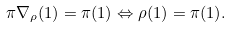<formula> <loc_0><loc_0><loc_500><loc_500>\pi \nabla _ { \rho } ( 1 ) = \pi ( 1 ) \Leftrightarrow \rho ( 1 ) = \pi ( 1 ) .</formula> 